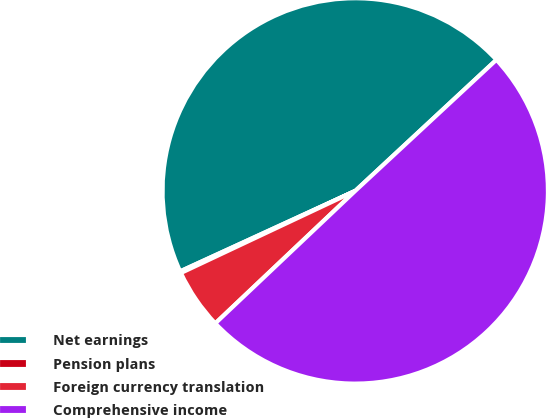<chart> <loc_0><loc_0><loc_500><loc_500><pie_chart><fcel>Net earnings<fcel>Pension plans<fcel>Foreign currency translation<fcel>Comprehensive income<nl><fcel>44.94%<fcel>0.15%<fcel>5.06%<fcel>49.85%<nl></chart> 